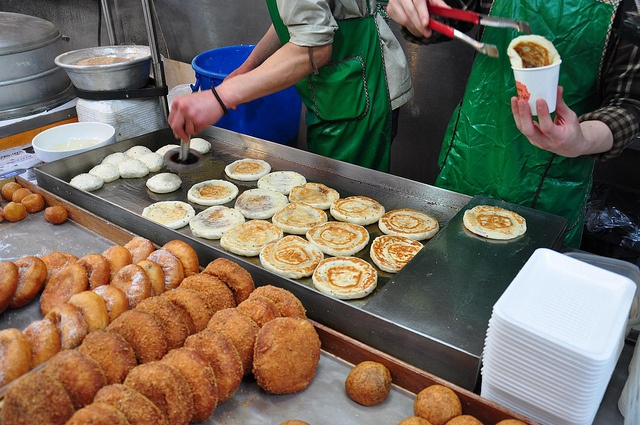Describe the objects in this image and their specific colors. I can see people in black, darkgreen, and brown tones, donut in black, brown, tan, salmon, and maroon tones, people in black, darkgreen, darkgray, and lightpink tones, donut in black, brown, tan, maroon, and salmon tones, and bowl in black, darkgray, gray, and lightgray tones in this image. 